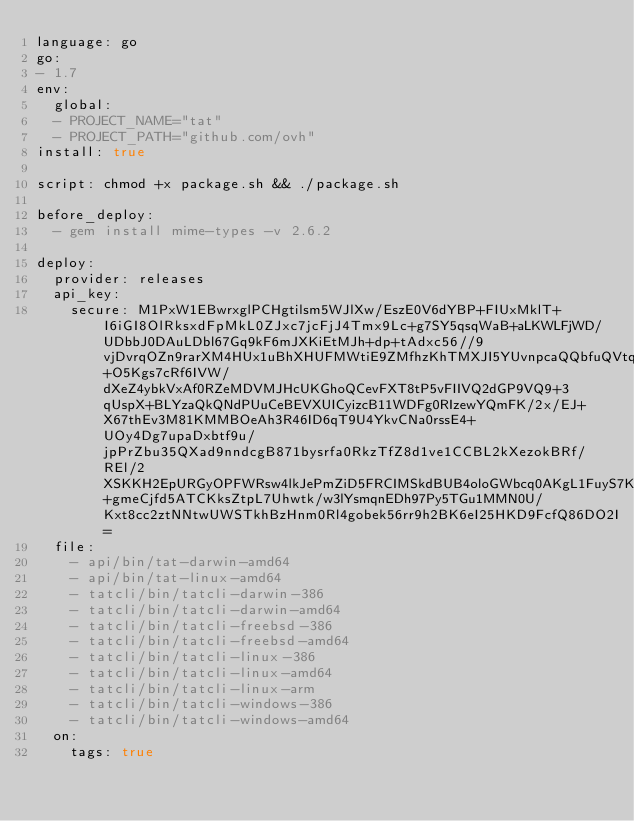Convert code to text. <code><loc_0><loc_0><loc_500><loc_500><_YAML_>language: go
go:
- 1.7
env:
  global:
  - PROJECT_NAME="tat"
  - PROJECT_PATH="github.com/ovh"
install: true

script: chmod +x package.sh && ./package.sh

before_deploy:
  - gem install mime-types -v 2.6.2

deploy:
  provider: releases
  api_key:
    secure: M1PxW1EBwrxglPCHgtilsm5WJlXw/EszE0V6dYBP+FIUxMklT+I6iGI8OlRksxdFpMkL0ZJxc7jcFjJ4Tmx9Lc+g7SY5qsqWaB+aLKWLFjWD/UDbbJ0DAuLDbl67Gq9kF6mJXKiEtMJh+dp+tAdxc56//9vjDvrqOZn9rarXM4HUx1uBhXHUFMWtiE9ZMfhzKhTMXJI5YUvnpcaQQbfuQVtqia0AiTcDzp5hFjbMQAhnYE7z6sNAIT+O5Kgs7cRf6IVW/dXeZ4ybkVxAf0RZeMDVMJHcUKGhoQCevFXT8tP5vFIIVQ2dGP9VQ9+3qUspX+BLYzaQkQNdPUuCeBEVXUICyizcB11WDFg0RIzewYQmFK/2x/EJ+X67thEv3M81KMMBOeAh3R46ID6qT9U4YkvCNa0rssE4+UOy4Dg7upaDxbtf9u/jpPrZbu35QXad9nndcgB871bysrfa0RkzTfZ8d1ve1CCBL2kXezokBRf/REl/2XSKKH2EpURGyOPFWRsw4lkJePmZiD5FRCIMSkdBUB4oloGWbcq0AKgL1FuyS7Kvxxwf0UYfQq+gmeCjfd5ATCKksZtpL7Uhwtk/w3lYsmqnEDh97Py5TGu1MMN0U/Kxt8cc2ztNNtwUWSTkhBzHnm0Rl4gobek56rr9h2BK6eI25HKD9FcfQ86DO2I=
  file:
    - api/bin/tat-darwin-amd64
    - api/bin/tat-linux-amd64
    - tatcli/bin/tatcli-darwin-386
    - tatcli/bin/tatcli-darwin-amd64
    - tatcli/bin/tatcli-freebsd-386
    - tatcli/bin/tatcli-freebsd-amd64
    - tatcli/bin/tatcli-linux-386
    - tatcli/bin/tatcli-linux-amd64
    - tatcli/bin/tatcli-linux-arm
    - tatcli/bin/tatcli-windows-386
    - tatcli/bin/tatcli-windows-amd64
  on:
    tags: true
</code> 